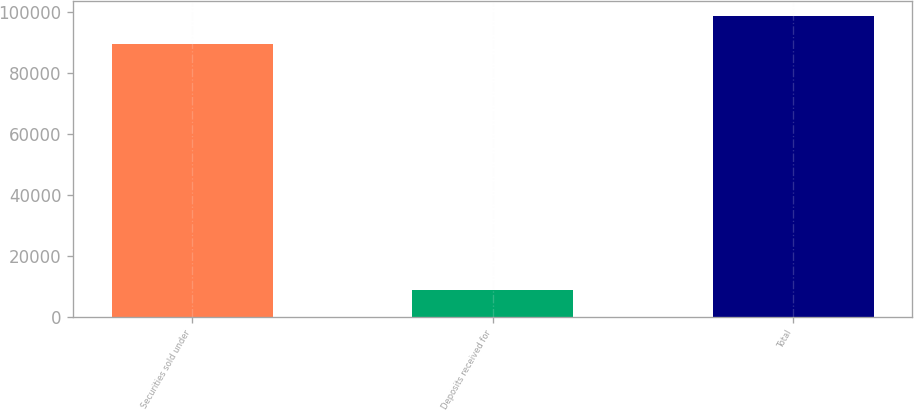<chart> <loc_0><loc_0><loc_500><loc_500><bar_chart><fcel>Securities sold under<fcel>Deposits received for<fcel>Total<nl><fcel>89732<fcel>9096<fcel>98828<nl></chart> 